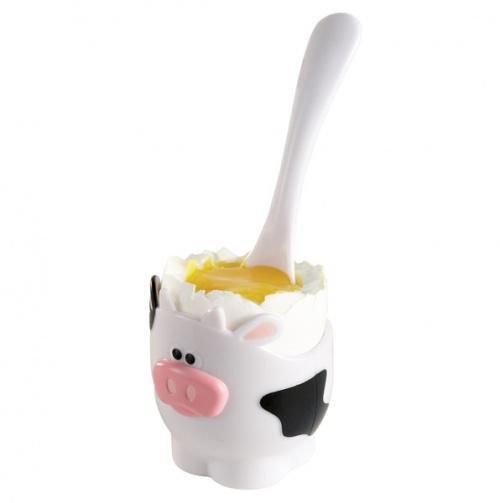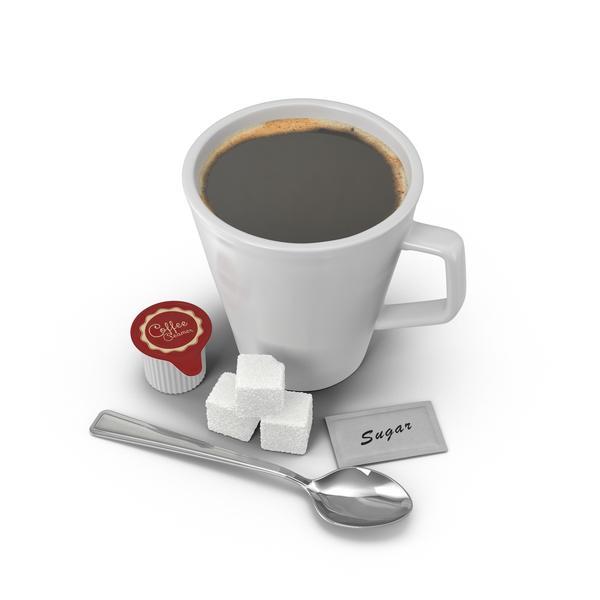The first image is the image on the left, the second image is the image on the right. Assess this claim about the two images: "The egg in the image on the right is brown.". Correct or not? Answer yes or no. No. 